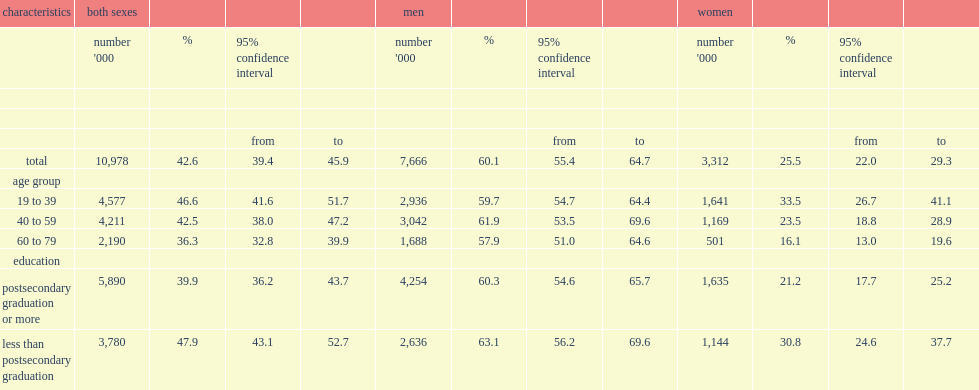How many canadians aged 19 to 79 have worked in noisy environments? 10978.0. Which sex is more to experience noisy workplaces? Men. Which women age group is most likely to experience a history of work in noisy environments? 19 to 39. 